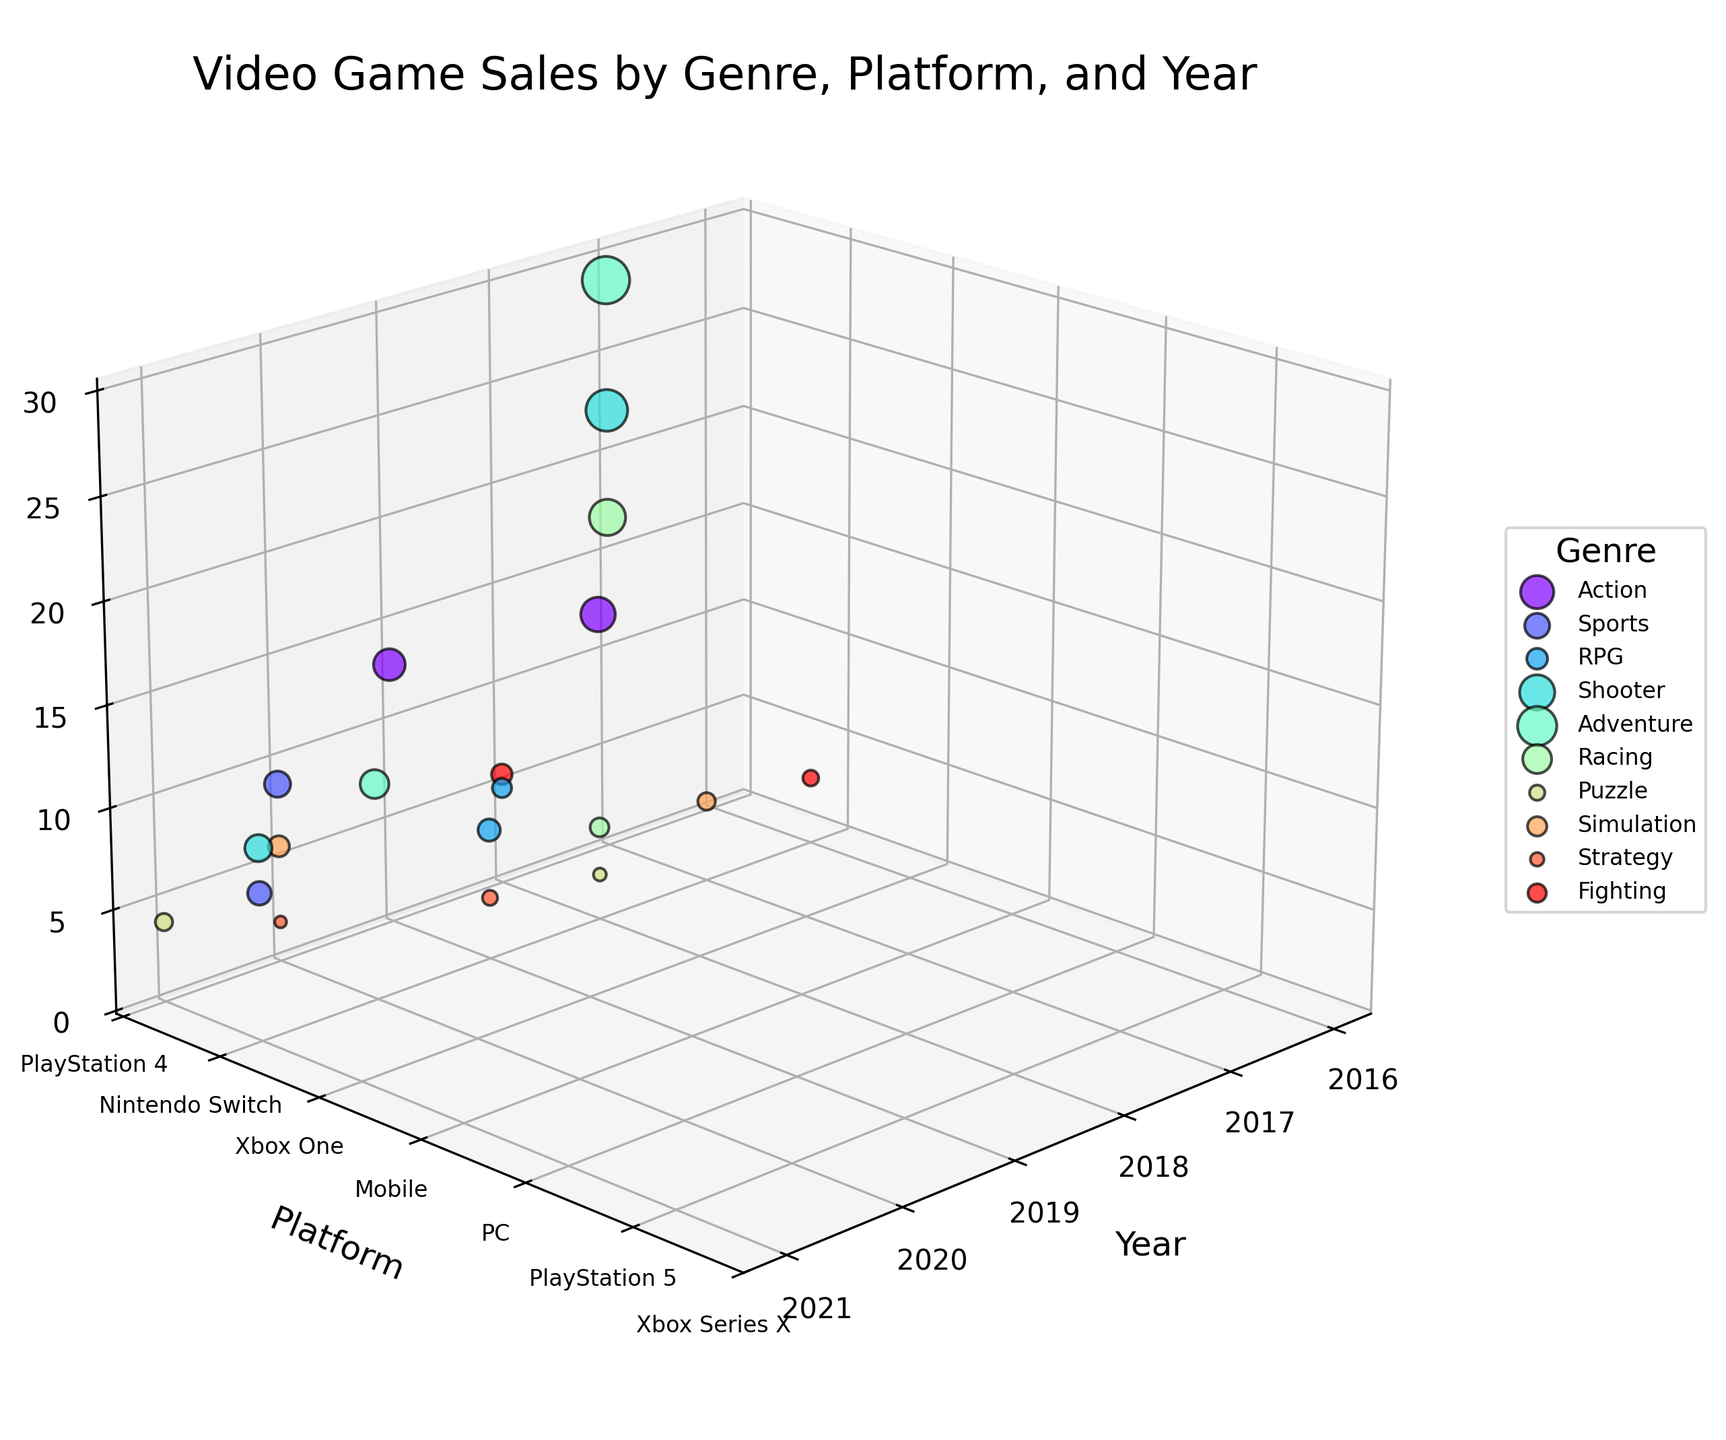What is the title of the figure? The title of the figure is displayed prominently at the top of the plot, usually in a larger and bold font.
Answer: Video Game Sales by Genre, Platform, and Year Which genre is represented by the color that occupies the highest region along the sales axis (Z-axis)? The highest point on the Z-axis correlates to the Adventure genre for Nintendo Switch in 2017, easily identifiable by the color-coded genre legend.
Answer: Adventure How many unique platforms are shown in the figure? The Y-axis of the plot has tick labels corresponding to each platform. By counting the distinct labels, we get the number of unique platforms.
Answer: 7 Which platform shows the highest sales for the Shooter genre across all years? By observing the points labeled "Shooter," we see the highest point along the Z-axis is for PlayStation 4 in 2017.
Answer: PlayStation 4 In which year did the sales for Racing games on the Nintendo Switch peak? By locating the genre "Racing" and filtering for Nintendo Switch (based on Y-axis positioning), we note that the highest sales point occurs in 2017.
Answer: 2017 What is the average sales for Adventure genre on any platform in 2017? Identify the sales for Adventure games in 2017: 28.6 (Nintendo Switch). Since there is only one data point, the average is simply this value.
Answer: 28.6 million Which platform had the lowest sales in the year 2021, and for which genre? Filter the data points for the year 2021 and compare their Z-axis values to find the lowest one. The lowest sales are 1.8 million, for Strategy on Mobile.
Answer: Mobile, Strategy Compare the sales of Action games on PlayStation 4 in 2018 to those on Nintendo Switch in 2019. Which one had higher sales, and by how much? Sales for Action on PlayStation 4 in 2018 = 15.2 million. Sales for Action on Nintendo Switch in 2019 = 12.8 million. The difference is 15.2 - 12.8 = 2.4 million.
Answer: PlayStation 4, 2.4 million How many different genres are represented in the figure? The legend in the figure lists each genre along with its distinct color, allowing an easy count of the unique genres.
Answer: 9 